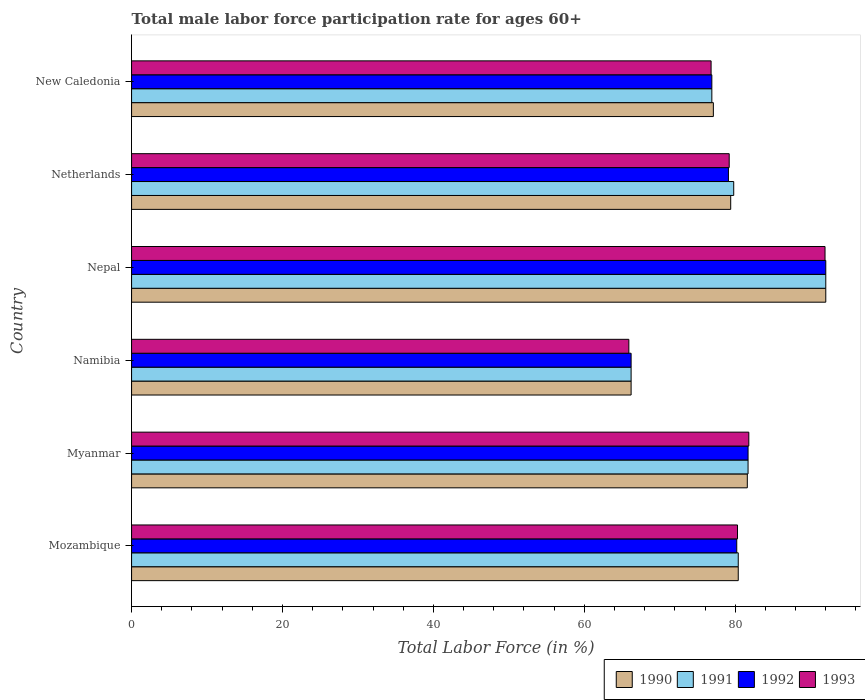How many bars are there on the 2nd tick from the top?
Provide a succinct answer. 4. How many bars are there on the 5th tick from the bottom?
Offer a very short reply. 4. What is the label of the 4th group of bars from the top?
Ensure brevity in your answer.  Namibia. What is the male labor force participation rate in 1992 in Myanmar?
Provide a succinct answer. 81.7. Across all countries, what is the maximum male labor force participation rate in 1992?
Provide a succinct answer. 92. Across all countries, what is the minimum male labor force participation rate in 1993?
Your answer should be very brief. 65.9. In which country was the male labor force participation rate in 1993 maximum?
Make the answer very short. Nepal. In which country was the male labor force participation rate in 1990 minimum?
Offer a terse response. Namibia. What is the total male labor force participation rate in 1993 in the graph?
Make the answer very short. 475.9. What is the difference between the male labor force participation rate in 1992 in Nepal and that in New Caledonia?
Offer a very short reply. 15.1. What is the average male labor force participation rate in 1990 per country?
Make the answer very short. 79.45. In how many countries, is the male labor force participation rate in 1992 greater than 8 %?
Make the answer very short. 6. What is the ratio of the male labor force participation rate in 1992 in Myanmar to that in Nepal?
Make the answer very short. 0.89. Is the difference between the male labor force participation rate in 1991 in Myanmar and Netherlands greater than the difference between the male labor force participation rate in 1990 in Myanmar and Netherlands?
Your answer should be compact. No. What is the difference between the highest and the second highest male labor force participation rate in 1993?
Your answer should be compact. 10.1. What is the difference between the highest and the lowest male labor force participation rate in 1991?
Keep it short and to the point. 25.8. What does the 3rd bar from the top in New Caledonia represents?
Provide a succinct answer. 1991. How many bars are there?
Offer a terse response. 24. Are all the bars in the graph horizontal?
Ensure brevity in your answer.  Yes. What is the difference between two consecutive major ticks on the X-axis?
Make the answer very short. 20. Does the graph contain any zero values?
Provide a short and direct response. No. What is the title of the graph?
Provide a succinct answer. Total male labor force participation rate for ages 60+. What is the Total Labor Force (in %) of 1990 in Mozambique?
Your answer should be very brief. 80.4. What is the Total Labor Force (in %) of 1991 in Mozambique?
Give a very brief answer. 80.4. What is the Total Labor Force (in %) in 1992 in Mozambique?
Provide a succinct answer. 80.2. What is the Total Labor Force (in %) of 1993 in Mozambique?
Give a very brief answer. 80.3. What is the Total Labor Force (in %) of 1990 in Myanmar?
Keep it short and to the point. 81.6. What is the Total Labor Force (in %) in 1991 in Myanmar?
Give a very brief answer. 81.7. What is the Total Labor Force (in %) of 1992 in Myanmar?
Your answer should be very brief. 81.7. What is the Total Labor Force (in %) in 1993 in Myanmar?
Your response must be concise. 81.8. What is the Total Labor Force (in %) in 1990 in Namibia?
Ensure brevity in your answer.  66.2. What is the Total Labor Force (in %) in 1991 in Namibia?
Give a very brief answer. 66.2. What is the Total Labor Force (in %) in 1992 in Namibia?
Provide a short and direct response. 66.2. What is the Total Labor Force (in %) in 1993 in Namibia?
Give a very brief answer. 65.9. What is the Total Labor Force (in %) of 1990 in Nepal?
Keep it short and to the point. 92. What is the Total Labor Force (in %) of 1991 in Nepal?
Provide a succinct answer. 92. What is the Total Labor Force (in %) of 1992 in Nepal?
Provide a short and direct response. 92. What is the Total Labor Force (in %) of 1993 in Nepal?
Keep it short and to the point. 91.9. What is the Total Labor Force (in %) of 1990 in Netherlands?
Offer a very short reply. 79.4. What is the Total Labor Force (in %) of 1991 in Netherlands?
Your answer should be compact. 79.8. What is the Total Labor Force (in %) of 1992 in Netherlands?
Provide a short and direct response. 79.1. What is the Total Labor Force (in %) of 1993 in Netherlands?
Offer a terse response. 79.2. What is the Total Labor Force (in %) in 1990 in New Caledonia?
Your response must be concise. 77.1. What is the Total Labor Force (in %) of 1991 in New Caledonia?
Offer a terse response. 76.9. What is the Total Labor Force (in %) of 1992 in New Caledonia?
Offer a terse response. 76.9. What is the Total Labor Force (in %) of 1993 in New Caledonia?
Provide a short and direct response. 76.8. Across all countries, what is the maximum Total Labor Force (in %) of 1990?
Offer a terse response. 92. Across all countries, what is the maximum Total Labor Force (in %) in 1991?
Your answer should be compact. 92. Across all countries, what is the maximum Total Labor Force (in %) in 1992?
Keep it short and to the point. 92. Across all countries, what is the maximum Total Labor Force (in %) in 1993?
Give a very brief answer. 91.9. Across all countries, what is the minimum Total Labor Force (in %) in 1990?
Ensure brevity in your answer.  66.2. Across all countries, what is the minimum Total Labor Force (in %) of 1991?
Your answer should be compact. 66.2. Across all countries, what is the minimum Total Labor Force (in %) of 1992?
Offer a very short reply. 66.2. Across all countries, what is the minimum Total Labor Force (in %) in 1993?
Offer a very short reply. 65.9. What is the total Total Labor Force (in %) in 1990 in the graph?
Keep it short and to the point. 476.7. What is the total Total Labor Force (in %) of 1991 in the graph?
Your answer should be compact. 477. What is the total Total Labor Force (in %) of 1992 in the graph?
Provide a succinct answer. 476.1. What is the total Total Labor Force (in %) of 1993 in the graph?
Your response must be concise. 475.9. What is the difference between the Total Labor Force (in %) of 1990 in Mozambique and that in Myanmar?
Your response must be concise. -1.2. What is the difference between the Total Labor Force (in %) of 1991 in Mozambique and that in Myanmar?
Your response must be concise. -1.3. What is the difference between the Total Labor Force (in %) in 1992 in Mozambique and that in Myanmar?
Offer a terse response. -1.5. What is the difference between the Total Labor Force (in %) in 1991 in Mozambique and that in Namibia?
Offer a very short reply. 14.2. What is the difference between the Total Labor Force (in %) in 1993 in Mozambique and that in Namibia?
Give a very brief answer. 14.4. What is the difference between the Total Labor Force (in %) in 1992 in Mozambique and that in Netherlands?
Provide a succinct answer. 1.1. What is the difference between the Total Labor Force (in %) of 1993 in Mozambique and that in Netherlands?
Offer a very short reply. 1.1. What is the difference between the Total Labor Force (in %) in 1990 in Myanmar and that in Namibia?
Offer a very short reply. 15.4. What is the difference between the Total Labor Force (in %) in 1992 in Myanmar and that in Namibia?
Ensure brevity in your answer.  15.5. What is the difference between the Total Labor Force (in %) of 1990 in Myanmar and that in Nepal?
Give a very brief answer. -10.4. What is the difference between the Total Labor Force (in %) in 1992 in Myanmar and that in Nepal?
Your answer should be very brief. -10.3. What is the difference between the Total Labor Force (in %) of 1990 in Myanmar and that in Netherlands?
Provide a short and direct response. 2.2. What is the difference between the Total Labor Force (in %) in 1993 in Myanmar and that in Netherlands?
Your response must be concise. 2.6. What is the difference between the Total Labor Force (in %) of 1992 in Myanmar and that in New Caledonia?
Make the answer very short. 4.8. What is the difference between the Total Labor Force (in %) in 1993 in Myanmar and that in New Caledonia?
Provide a succinct answer. 5. What is the difference between the Total Labor Force (in %) of 1990 in Namibia and that in Nepal?
Give a very brief answer. -25.8. What is the difference between the Total Labor Force (in %) in 1991 in Namibia and that in Nepal?
Give a very brief answer. -25.8. What is the difference between the Total Labor Force (in %) of 1992 in Namibia and that in Nepal?
Your response must be concise. -25.8. What is the difference between the Total Labor Force (in %) in 1991 in Namibia and that in Netherlands?
Provide a short and direct response. -13.6. What is the difference between the Total Labor Force (in %) in 1993 in Namibia and that in Netherlands?
Keep it short and to the point. -13.3. What is the difference between the Total Labor Force (in %) in 1992 in Namibia and that in New Caledonia?
Offer a very short reply. -10.7. What is the difference between the Total Labor Force (in %) of 1990 in Nepal and that in Netherlands?
Provide a short and direct response. 12.6. What is the difference between the Total Labor Force (in %) of 1993 in Nepal and that in Netherlands?
Provide a short and direct response. 12.7. What is the difference between the Total Labor Force (in %) in 1990 in Nepal and that in New Caledonia?
Your answer should be compact. 14.9. What is the difference between the Total Labor Force (in %) of 1991 in Nepal and that in New Caledonia?
Keep it short and to the point. 15.1. What is the difference between the Total Labor Force (in %) in 1992 in Nepal and that in New Caledonia?
Your response must be concise. 15.1. What is the difference between the Total Labor Force (in %) of 1990 in Netherlands and that in New Caledonia?
Offer a very short reply. 2.3. What is the difference between the Total Labor Force (in %) in 1992 in Netherlands and that in New Caledonia?
Offer a very short reply. 2.2. What is the difference between the Total Labor Force (in %) of 1993 in Netherlands and that in New Caledonia?
Keep it short and to the point. 2.4. What is the difference between the Total Labor Force (in %) in 1990 in Mozambique and the Total Labor Force (in %) in 1992 in Myanmar?
Your response must be concise. -1.3. What is the difference between the Total Labor Force (in %) of 1991 in Mozambique and the Total Labor Force (in %) of 1993 in Myanmar?
Provide a short and direct response. -1.4. What is the difference between the Total Labor Force (in %) of 1990 in Mozambique and the Total Labor Force (in %) of 1991 in Namibia?
Provide a succinct answer. 14.2. What is the difference between the Total Labor Force (in %) in 1990 in Mozambique and the Total Labor Force (in %) in 1992 in Namibia?
Keep it short and to the point. 14.2. What is the difference between the Total Labor Force (in %) of 1990 in Mozambique and the Total Labor Force (in %) of 1993 in Namibia?
Keep it short and to the point. 14.5. What is the difference between the Total Labor Force (in %) of 1991 in Mozambique and the Total Labor Force (in %) of 1992 in Namibia?
Provide a succinct answer. 14.2. What is the difference between the Total Labor Force (in %) of 1991 in Mozambique and the Total Labor Force (in %) of 1993 in Namibia?
Offer a terse response. 14.5. What is the difference between the Total Labor Force (in %) of 1992 in Mozambique and the Total Labor Force (in %) of 1993 in Namibia?
Provide a succinct answer. 14.3. What is the difference between the Total Labor Force (in %) of 1990 in Mozambique and the Total Labor Force (in %) of 1991 in Nepal?
Offer a terse response. -11.6. What is the difference between the Total Labor Force (in %) of 1990 in Mozambique and the Total Labor Force (in %) of 1992 in Nepal?
Give a very brief answer. -11.6. What is the difference between the Total Labor Force (in %) of 1990 in Mozambique and the Total Labor Force (in %) of 1993 in Nepal?
Your answer should be compact. -11.5. What is the difference between the Total Labor Force (in %) of 1991 in Mozambique and the Total Labor Force (in %) of 1993 in Nepal?
Your answer should be very brief. -11.5. What is the difference between the Total Labor Force (in %) of 1992 in Mozambique and the Total Labor Force (in %) of 1993 in Nepal?
Ensure brevity in your answer.  -11.7. What is the difference between the Total Labor Force (in %) in 1990 in Mozambique and the Total Labor Force (in %) in 1991 in Netherlands?
Offer a very short reply. 0.6. What is the difference between the Total Labor Force (in %) of 1990 in Mozambique and the Total Labor Force (in %) of 1991 in New Caledonia?
Keep it short and to the point. 3.5. What is the difference between the Total Labor Force (in %) in 1990 in Mozambique and the Total Labor Force (in %) in 1993 in New Caledonia?
Provide a succinct answer. 3.6. What is the difference between the Total Labor Force (in %) in 1991 in Mozambique and the Total Labor Force (in %) in 1992 in New Caledonia?
Your response must be concise. 3.5. What is the difference between the Total Labor Force (in %) of 1991 in Myanmar and the Total Labor Force (in %) of 1993 in Namibia?
Your response must be concise. 15.8. What is the difference between the Total Labor Force (in %) in 1991 in Myanmar and the Total Labor Force (in %) in 1992 in Nepal?
Your answer should be compact. -10.3. What is the difference between the Total Labor Force (in %) of 1990 in Myanmar and the Total Labor Force (in %) of 1991 in Netherlands?
Make the answer very short. 1.8. What is the difference between the Total Labor Force (in %) in 1990 in Myanmar and the Total Labor Force (in %) in 1992 in Netherlands?
Offer a very short reply. 2.5. What is the difference between the Total Labor Force (in %) of 1990 in Myanmar and the Total Labor Force (in %) of 1993 in Netherlands?
Your answer should be very brief. 2.4. What is the difference between the Total Labor Force (in %) of 1991 in Myanmar and the Total Labor Force (in %) of 1992 in Netherlands?
Provide a succinct answer. 2.6. What is the difference between the Total Labor Force (in %) in 1991 in Myanmar and the Total Labor Force (in %) in 1993 in Netherlands?
Keep it short and to the point. 2.5. What is the difference between the Total Labor Force (in %) in 1990 in Myanmar and the Total Labor Force (in %) in 1991 in New Caledonia?
Give a very brief answer. 4.7. What is the difference between the Total Labor Force (in %) of 1990 in Myanmar and the Total Labor Force (in %) of 1993 in New Caledonia?
Your answer should be very brief. 4.8. What is the difference between the Total Labor Force (in %) in 1990 in Namibia and the Total Labor Force (in %) in 1991 in Nepal?
Make the answer very short. -25.8. What is the difference between the Total Labor Force (in %) of 1990 in Namibia and the Total Labor Force (in %) of 1992 in Nepal?
Your answer should be very brief. -25.8. What is the difference between the Total Labor Force (in %) of 1990 in Namibia and the Total Labor Force (in %) of 1993 in Nepal?
Your response must be concise. -25.7. What is the difference between the Total Labor Force (in %) in 1991 in Namibia and the Total Labor Force (in %) in 1992 in Nepal?
Make the answer very short. -25.8. What is the difference between the Total Labor Force (in %) in 1991 in Namibia and the Total Labor Force (in %) in 1993 in Nepal?
Your response must be concise. -25.7. What is the difference between the Total Labor Force (in %) of 1992 in Namibia and the Total Labor Force (in %) of 1993 in Nepal?
Offer a very short reply. -25.7. What is the difference between the Total Labor Force (in %) of 1990 in Namibia and the Total Labor Force (in %) of 1991 in Netherlands?
Your response must be concise. -13.6. What is the difference between the Total Labor Force (in %) of 1991 in Namibia and the Total Labor Force (in %) of 1992 in Netherlands?
Provide a succinct answer. -12.9. What is the difference between the Total Labor Force (in %) of 1991 in Namibia and the Total Labor Force (in %) of 1993 in Netherlands?
Offer a very short reply. -13. What is the difference between the Total Labor Force (in %) in 1992 in Namibia and the Total Labor Force (in %) in 1993 in Netherlands?
Ensure brevity in your answer.  -13. What is the difference between the Total Labor Force (in %) of 1990 in Namibia and the Total Labor Force (in %) of 1991 in New Caledonia?
Offer a very short reply. -10.7. What is the difference between the Total Labor Force (in %) of 1990 in Namibia and the Total Labor Force (in %) of 1993 in New Caledonia?
Your response must be concise. -10.6. What is the difference between the Total Labor Force (in %) in 1991 in Namibia and the Total Labor Force (in %) in 1992 in New Caledonia?
Your response must be concise. -10.7. What is the difference between the Total Labor Force (in %) of 1991 in Namibia and the Total Labor Force (in %) of 1993 in New Caledonia?
Keep it short and to the point. -10.6. What is the difference between the Total Labor Force (in %) in 1992 in Namibia and the Total Labor Force (in %) in 1993 in New Caledonia?
Give a very brief answer. -10.6. What is the difference between the Total Labor Force (in %) of 1990 in Nepal and the Total Labor Force (in %) of 1992 in Netherlands?
Offer a very short reply. 12.9. What is the difference between the Total Labor Force (in %) of 1990 in Nepal and the Total Labor Force (in %) of 1993 in Netherlands?
Offer a terse response. 12.8. What is the difference between the Total Labor Force (in %) of 1991 in Nepal and the Total Labor Force (in %) of 1992 in Netherlands?
Give a very brief answer. 12.9. What is the difference between the Total Labor Force (in %) in 1990 in Nepal and the Total Labor Force (in %) in 1991 in New Caledonia?
Provide a succinct answer. 15.1. What is the difference between the Total Labor Force (in %) in 1990 in Nepal and the Total Labor Force (in %) in 1992 in New Caledonia?
Your response must be concise. 15.1. What is the difference between the Total Labor Force (in %) of 1990 in Nepal and the Total Labor Force (in %) of 1993 in New Caledonia?
Give a very brief answer. 15.2. What is the difference between the Total Labor Force (in %) in 1991 in Nepal and the Total Labor Force (in %) in 1992 in New Caledonia?
Your answer should be compact. 15.1. What is the difference between the Total Labor Force (in %) of 1991 in Nepal and the Total Labor Force (in %) of 1993 in New Caledonia?
Ensure brevity in your answer.  15.2. What is the difference between the Total Labor Force (in %) of 1990 in Netherlands and the Total Labor Force (in %) of 1991 in New Caledonia?
Provide a succinct answer. 2.5. What is the difference between the Total Labor Force (in %) in 1990 in Netherlands and the Total Labor Force (in %) in 1992 in New Caledonia?
Your answer should be very brief. 2.5. What is the difference between the Total Labor Force (in %) in 1990 in Netherlands and the Total Labor Force (in %) in 1993 in New Caledonia?
Offer a very short reply. 2.6. What is the difference between the Total Labor Force (in %) of 1991 in Netherlands and the Total Labor Force (in %) of 1992 in New Caledonia?
Your answer should be very brief. 2.9. What is the difference between the Total Labor Force (in %) in 1991 in Netherlands and the Total Labor Force (in %) in 1993 in New Caledonia?
Make the answer very short. 3. What is the difference between the Total Labor Force (in %) of 1992 in Netherlands and the Total Labor Force (in %) of 1993 in New Caledonia?
Make the answer very short. 2.3. What is the average Total Labor Force (in %) in 1990 per country?
Keep it short and to the point. 79.45. What is the average Total Labor Force (in %) in 1991 per country?
Keep it short and to the point. 79.5. What is the average Total Labor Force (in %) in 1992 per country?
Your response must be concise. 79.35. What is the average Total Labor Force (in %) in 1993 per country?
Ensure brevity in your answer.  79.32. What is the difference between the Total Labor Force (in %) in 1990 and Total Labor Force (in %) in 1992 in Mozambique?
Your response must be concise. 0.2. What is the difference between the Total Labor Force (in %) of 1990 and Total Labor Force (in %) of 1993 in Mozambique?
Your answer should be very brief. 0.1. What is the difference between the Total Labor Force (in %) in 1991 and Total Labor Force (in %) in 1993 in Mozambique?
Make the answer very short. 0.1. What is the difference between the Total Labor Force (in %) in 1992 and Total Labor Force (in %) in 1993 in Mozambique?
Keep it short and to the point. -0.1. What is the difference between the Total Labor Force (in %) of 1990 and Total Labor Force (in %) of 1992 in Myanmar?
Your response must be concise. -0.1. What is the difference between the Total Labor Force (in %) of 1991 and Total Labor Force (in %) of 1993 in Namibia?
Offer a terse response. 0.3. What is the difference between the Total Labor Force (in %) in 1990 and Total Labor Force (in %) in 1992 in Nepal?
Keep it short and to the point. 0. What is the difference between the Total Labor Force (in %) in 1991 and Total Labor Force (in %) in 1992 in Nepal?
Give a very brief answer. 0. What is the difference between the Total Labor Force (in %) in 1991 and Total Labor Force (in %) in 1993 in Nepal?
Give a very brief answer. 0.1. What is the difference between the Total Labor Force (in %) in 1992 and Total Labor Force (in %) in 1993 in Nepal?
Offer a very short reply. 0.1. What is the difference between the Total Labor Force (in %) of 1991 and Total Labor Force (in %) of 1992 in Netherlands?
Give a very brief answer. 0.7. What is the difference between the Total Labor Force (in %) in 1991 and Total Labor Force (in %) in 1993 in Netherlands?
Give a very brief answer. 0.6. What is the difference between the Total Labor Force (in %) of 1992 and Total Labor Force (in %) of 1993 in Netherlands?
Give a very brief answer. -0.1. What is the difference between the Total Labor Force (in %) in 1990 and Total Labor Force (in %) in 1991 in New Caledonia?
Make the answer very short. 0.2. What is the difference between the Total Labor Force (in %) in 1990 and Total Labor Force (in %) in 1992 in New Caledonia?
Your answer should be compact. 0.2. What is the difference between the Total Labor Force (in %) in 1991 and Total Labor Force (in %) in 1993 in New Caledonia?
Offer a very short reply. 0.1. What is the ratio of the Total Labor Force (in %) of 1991 in Mozambique to that in Myanmar?
Ensure brevity in your answer.  0.98. What is the ratio of the Total Labor Force (in %) in 1992 in Mozambique to that in Myanmar?
Keep it short and to the point. 0.98. What is the ratio of the Total Labor Force (in %) of 1993 in Mozambique to that in Myanmar?
Your answer should be very brief. 0.98. What is the ratio of the Total Labor Force (in %) in 1990 in Mozambique to that in Namibia?
Offer a terse response. 1.21. What is the ratio of the Total Labor Force (in %) in 1991 in Mozambique to that in Namibia?
Your response must be concise. 1.21. What is the ratio of the Total Labor Force (in %) in 1992 in Mozambique to that in Namibia?
Provide a succinct answer. 1.21. What is the ratio of the Total Labor Force (in %) in 1993 in Mozambique to that in Namibia?
Your response must be concise. 1.22. What is the ratio of the Total Labor Force (in %) of 1990 in Mozambique to that in Nepal?
Make the answer very short. 0.87. What is the ratio of the Total Labor Force (in %) of 1991 in Mozambique to that in Nepal?
Offer a terse response. 0.87. What is the ratio of the Total Labor Force (in %) in 1992 in Mozambique to that in Nepal?
Your response must be concise. 0.87. What is the ratio of the Total Labor Force (in %) of 1993 in Mozambique to that in Nepal?
Offer a very short reply. 0.87. What is the ratio of the Total Labor Force (in %) of 1990 in Mozambique to that in Netherlands?
Ensure brevity in your answer.  1.01. What is the ratio of the Total Labor Force (in %) of 1991 in Mozambique to that in Netherlands?
Keep it short and to the point. 1.01. What is the ratio of the Total Labor Force (in %) in 1992 in Mozambique to that in Netherlands?
Your answer should be very brief. 1.01. What is the ratio of the Total Labor Force (in %) in 1993 in Mozambique to that in Netherlands?
Provide a succinct answer. 1.01. What is the ratio of the Total Labor Force (in %) of 1990 in Mozambique to that in New Caledonia?
Offer a terse response. 1.04. What is the ratio of the Total Labor Force (in %) of 1991 in Mozambique to that in New Caledonia?
Your answer should be compact. 1.05. What is the ratio of the Total Labor Force (in %) of 1992 in Mozambique to that in New Caledonia?
Offer a very short reply. 1.04. What is the ratio of the Total Labor Force (in %) in 1993 in Mozambique to that in New Caledonia?
Offer a very short reply. 1.05. What is the ratio of the Total Labor Force (in %) of 1990 in Myanmar to that in Namibia?
Keep it short and to the point. 1.23. What is the ratio of the Total Labor Force (in %) of 1991 in Myanmar to that in Namibia?
Make the answer very short. 1.23. What is the ratio of the Total Labor Force (in %) of 1992 in Myanmar to that in Namibia?
Ensure brevity in your answer.  1.23. What is the ratio of the Total Labor Force (in %) in 1993 in Myanmar to that in Namibia?
Offer a terse response. 1.24. What is the ratio of the Total Labor Force (in %) in 1990 in Myanmar to that in Nepal?
Offer a terse response. 0.89. What is the ratio of the Total Labor Force (in %) in 1991 in Myanmar to that in Nepal?
Ensure brevity in your answer.  0.89. What is the ratio of the Total Labor Force (in %) in 1992 in Myanmar to that in Nepal?
Your response must be concise. 0.89. What is the ratio of the Total Labor Force (in %) of 1993 in Myanmar to that in Nepal?
Make the answer very short. 0.89. What is the ratio of the Total Labor Force (in %) of 1990 in Myanmar to that in Netherlands?
Your answer should be compact. 1.03. What is the ratio of the Total Labor Force (in %) of 1991 in Myanmar to that in Netherlands?
Give a very brief answer. 1.02. What is the ratio of the Total Labor Force (in %) of 1992 in Myanmar to that in Netherlands?
Offer a terse response. 1.03. What is the ratio of the Total Labor Force (in %) of 1993 in Myanmar to that in Netherlands?
Your answer should be very brief. 1.03. What is the ratio of the Total Labor Force (in %) in 1990 in Myanmar to that in New Caledonia?
Your answer should be compact. 1.06. What is the ratio of the Total Labor Force (in %) in 1991 in Myanmar to that in New Caledonia?
Provide a short and direct response. 1.06. What is the ratio of the Total Labor Force (in %) of 1992 in Myanmar to that in New Caledonia?
Provide a succinct answer. 1.06. What is the ratio of the Total Labor Force (in %) of 1993 in Myanmar to that in New Caledonia?
Provide a succinct answer. 1.07. What is the ratio of the Total Labor Force (in %) in 1990 in Namibia to that in Nepal?
Your response must be concise. 0.72. What is the ratio of the Total Labor Force (in %) of 1991 in Namibia to that in Nepal?
Keep it short and to the point. 0.72. What is the ratio of the Total Labor Force (in %) in 1992 in Namibia to that in Nepal?
Your answer should be compact. 0.72. What is the ratio of the Total Labor Force (in %) in 1993 in Namibia to that in Nepal?
Offer a very short reply. 0.72. What is the ratio of the Total Labor Force (in %) of 1990 in Namibia to that in Netherlands?
Give a very brief answer. 0.83. What is the ratio of the Total Labor Force (in %) of 1991 in Namibia to that in Netherlands?
Offer a very short reply. 0.83. What is the ratio of the Total Labor Force (in %) in 1992 in Namibia to that in Netherlands?
Your answer should be very brief. 0.84. What is the ratio of the Total Labor Force (in %) of 1993 in Namibia to that in Netherlands?
Keep it short and to the point. 0.83. What is the ratio of the Total Labor Force (in %) in 1990 in Namibia to that in New Caledonia?
Provide a short and direct response. 0.86. What is the ratio of the Total Labor Force (in %) of 1991 in Namibia to that in New Caledonia?
Give a very brief answer. 0.86. What is the ratio of the Total Labor Force (in %) of 1992 in Namibia to that in New Caledonia?
Your response must be concise. 0.86. What is the ratio of the Total Labor Force (in %) of 1993 in Namibia to that in New Caledonia?
Your answer should be very brief. 0.86. What is the ratio of the Total Labor Force (in %) in 1990 in Nepal to that in Netherlands?
Your response must be concise. 1.16. What is the ratio of the Total Labor Force (in %) of 1991 in Nepal to that in Netherlands?
Your answer should be very brief. 1.15. What is the ratio of the Total Labor Force (in %) in 1992 in Nepal to that in Netherlands?
Offer a terse response. 1.16. What is the ratio of the Total Labor Force (in %) of 1993 in Nepal to that in Netherlands?
Provide a succinct answer. 1.16. What is the ratio of the Total Labor Force (in %) in 1990 in Nepal to that in New Caledonia?
Make the answer very short. 1.19. What is the ratio of the Total Labor Force (in %) of 1991 in Nepal to that in New Caledonia?
Offer a very short reply. 1.2. What is the ratio of the Total Labor Force (in %) of 1992 in Nepal to that in New Caledonia?
Your response must be concise. 1.2. What is the ratio of the Total Labor Force (in %) of 1993 in Nepal to that in New Caledonia?
Give a very brief answer. 1.2. What is the ratio of the Total Labor Force (in %) of 1990 in Netherlands to that in New Caledonia?
Provide a succinct answer. 1.03. What is the ratio of the Total Labor Force (in %) in 1991 in Netherlands to that in New Caledonia?
Provide a succinct answer. 1.04. What is the ratio of the Total Labor Force (in %) in 1992 in Netherlands to that in New Caledonia?
Your answer should be compact. 1.03. What is the ratio of the Total Labor Force (in %) of 1993 in Netherlands to that in New Caledonia?
Offer a very short reply. 1.03. What is the difference between the highest and the second highest Total Labor Force (in %) of 1990?
Provide a succinct answer. 10.4. What is the difference between the highest and the second highest Total Labor Force (in %) of 1991?
Offer a very short reply. 10.3. What is the difference between the highest and the lowest Total Labor Force (in %) of 1990?
Provide a succinct answer. 25.8. What is the difference between the highest and the lowest Total Labor Force (in %) in 1991?
Ensure brevity in your answer.  25.8. What is the difference between the highest and the lowest Total Labor Force (in %) in 1992?
Keep it short and to the point. 25.8. 